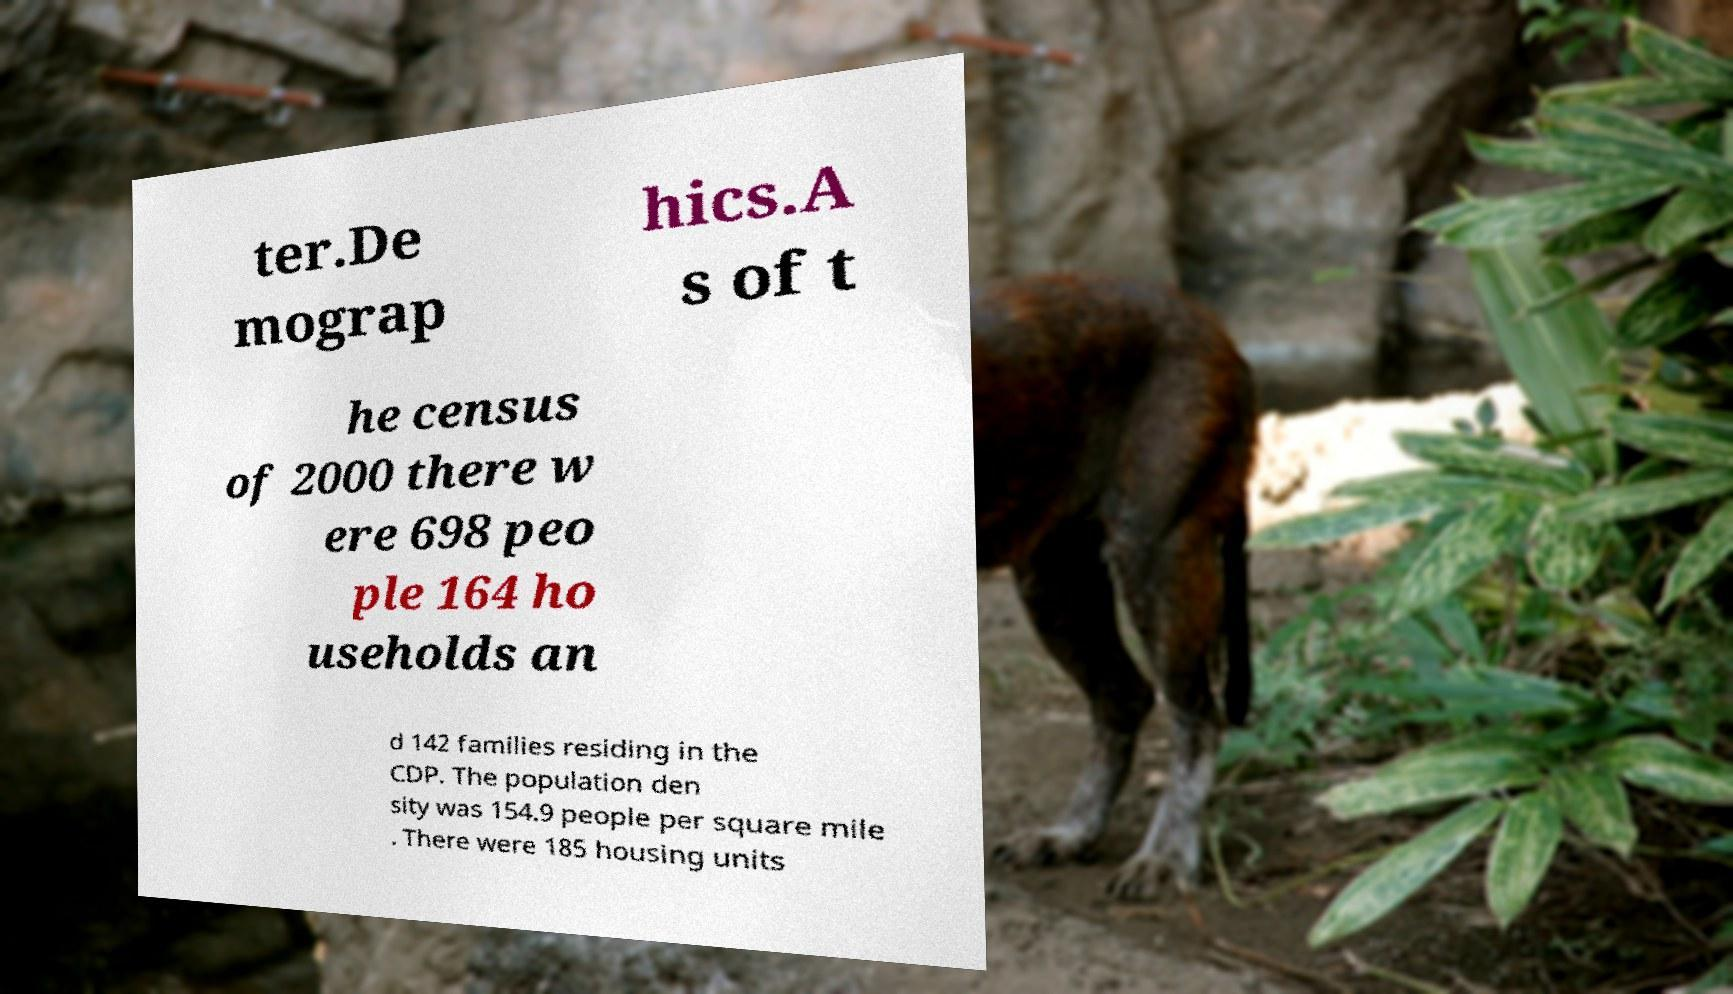I need the written content from this picture converted into text. Can you do that? ter.De mograp hics.A s of t he census of 2000 there w ere 698 peo ple 164 ho useholds an d 142 families residing in the CDP. The population den sity was 154.9 people per square mile . There were 185 housing units 